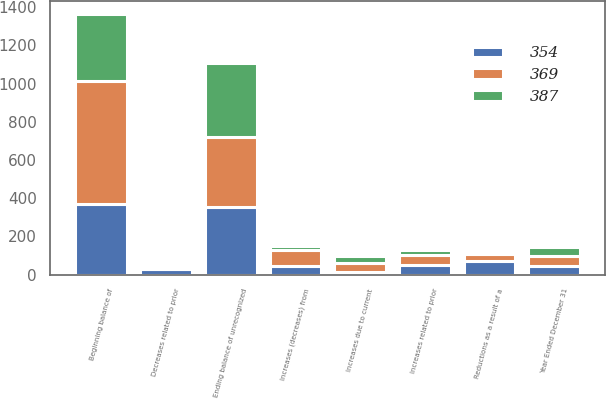<chart> <loc_0><loc_0><loc_500><loc_500><stacked_bar_chart><ecel><fcel>Year Ended December 31<fcel>Beginning balance of<fcel>Increases related to prior<fcel>Decreases related to prior<fcel>Increases due to current<fcel>Reductions as a result of a<fcel>Increases (decreases) from<fcel>Ending balance of unrecognized<nl><fcel>387<fcel>48<fcel>354<fcel>26<fcel>10<fcel>33<fcel>1<fcel>21<fcel>387<nl><fcel>354<fcel>48<fcel>369<fcel>49<fcel>28<fcel>16<fcel>73<fcel>48<fcel>354<nl><fcel>369<fcel>48<fcel>643<fcel>52<fcel>4<fcel>47<fcel>36<fcel>79<fcel>369<nl></chart> 